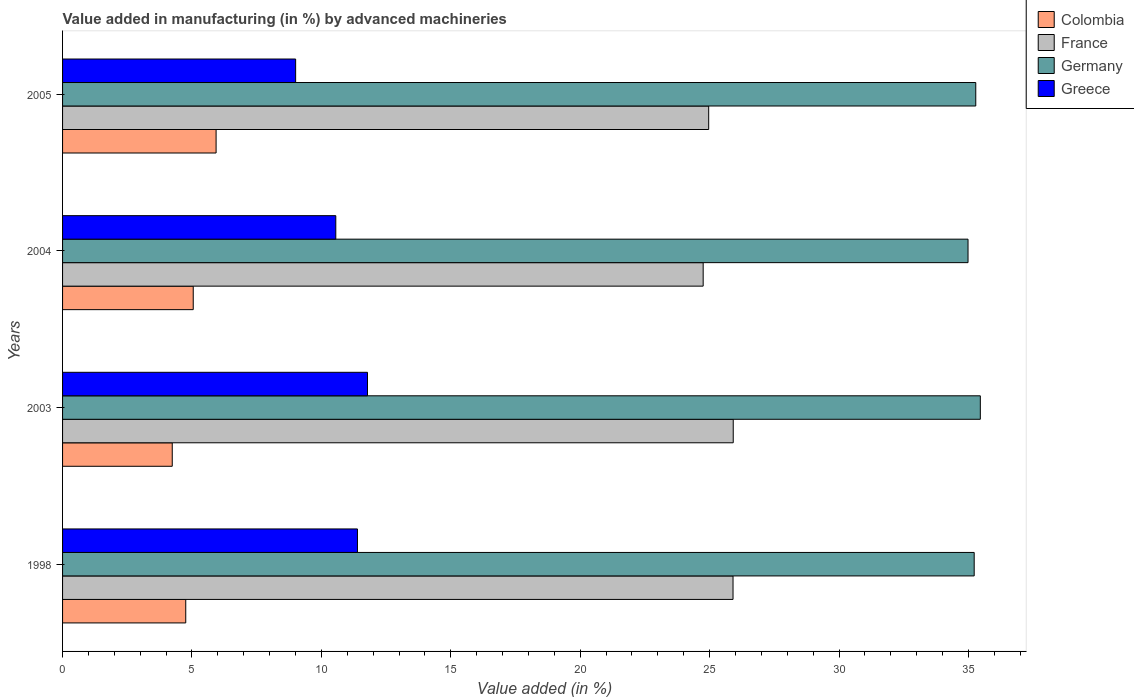Are the number of bars per tick equal to the number of legend labels?
Offer a terse response. Yes. How many bars are there on the 2nd tick from the bottom?
Ensure brevity in your answer.  4. What is the percentage of value added in manufacturing by advanced machineries in France in 2005?
Give a very brief answer. 24.96. Across all years, what is the maximum percentage of value added in manufacturing by advanced machineries in Germany?
Make the answer very short. 35.46. Across all years, what is the minimum percentage of value added in manufacturing by advanced machineries in Greece?
Provide a short and direct response. 9. What is the total percentage of value added in manufacturing by advanced machineries in France in the graph?
Your response must be concise. 101.53. What is the difference between the percentage of value added in manufacturing by advanced machineries in France in 2004 and that in 2005?
Your answer should be compact. -0.21. What is the difference between the percentage of value added in manufacturing by advanced machineries in Greece in 1998 and the percentage of value added in manufacturing by advanced machineries in Germany in 2003?
Offer a very short reply. -24.06. What is the average percentage of value added in manufacturing by advanced machineries in Colombia per year?
Provide a short and direct response. 4.99. In the year 2004, what is the difference between the percentage of value added in manufacturing by advanced machineries in France and percentage of value added in manufacturing by advanced machineries in Greece?
Your answer should be very brief. 14.19. What is the ratio of the percentage of value added in manufacturing by advanced machineries in Germany in 1998 to that in 2003?
Make the answer very short. 0.99. What is the difference between the highest and the second highest percentage of value added in manufacturing by advanced machineries in France?
Keep it short and to the point. 0.01. What is the difference between the highest and the lowest percentage of value added in manufacturing by advanced machineries in Germany?
Offer a very short reply. 0.48. Is it the case that in every year, the sum of the percentage of value added in manufacturing by advanced machineries in Colombia and percentage of value added in manufacturing by advanced machineries in Greece is greater than the sum of percentage of value added in manufacturing by advanced machineries in France and percentage of value added in manufacturing by advanced machineries in Germany?
Your answer should be very brief. No. What does the 1st bar from the top in 2004 represents?
Offer a terse response. Greece. What does the 2nd bar from the bottom in 2005 represents?
Keep it short and to the point. France. Is it the case that in every year, the sum of the percentage of value added in manufacturing by advanced machineries in France and percentage of value added in manufacturing by advanced machineries in Colombia is greater than the percentage of value added in manufacturing by advanced machineries in Germany?
Provide a succinct answer. No. How many bars are there?
Provide a short and direct response. 16. Are all the bars in the graph horizontal?
Provide a succinct answer. Yes. Where does the legend appear in the graph?
Ensure brevity in your answer.  Top right. How many legend labels are there?
Keep it short and to the point. 4. How are the legend labels stacked?
Keep it short and to the point. Vertical. What is the title of the graph?
Your response must be concise. Value added in manufacturing (in %) by advanced machineries. What is the label or title of the X-axis?
Give a very brief answer. Value added (in %). What is the Value added (in %) of Colombia in 1998?
Your response must be concise. 4.76. What is the Value added (in %) in France in 1998?
Give a very brief answer. 25.9. What is the Value added (in %) of Germany in 1998?
Keep it short and to the point. 35.22. What is the Value added (in %) of Greece in 1998?
Offer a very short reply. 11.39. What is the Value added (in %) in Colombia in 2003?
Give a very brief answer. 4.24. What is the Value added (in %) of France in 2003?
Your response must be concise. 25.91. What is the Value added (in %) of Germany in 2003?
Provide a short and direct response. 35.46. What is the Value added (in %) in Greece in 2003?
Your answer should be very brief. 11.78. What is the Value added (in %) of Colombia in 2004?
Ensure brevity in your answer.  5.05. What is the Value added (in %) of France in 2004?
Your answer should be very brief. 24.75. What is the Value added (in %) of Germany in 2004?
Provide a short and direct response. 34.98. What is the Value added (in %) of Greece in 2004?
Give a very brief answer. 10.56. What is the Value added (in %) of Colombia in 2005?
Provide a short and direct response. 5.93. What is the Value added (in %) in France in 2005?
Your answer should be very brief. 24.96. What is the Value added (in %) of Germany in 2005?
Keep it short and to the point. 35.28. What is the Value added (in %) of Greece in 2005?
Offer a very short reply. 9. Across all years, what is the maximum Value added (in %) of Colombia?
Give a very brief answer. 5.93. Across all years, what is the maximum Value added (in %) in France?
Provide a succinct answer. 25.91. Across all years, what is the maximum Value added (in %) in Germany?
Provide a succinct answer. 35.46. Across all years, what is the maximum Value added (in %) of Greece?
Provide a short and direct response. 11.78. Across all years, what is the minimum Value added (in %) of Colombia?
Your answer should be very brief. 4.24. Across all years, what is the minimum Value added (in %) of France?
Ensure brevity in your answer.  24.75. Across all years, what is the minimum Value added (in %) in Germany?
Keep it short and to the point. 34.98. Across all years, what is the minimum Value added (in %) of Greece?
Give a very brief answer. 9. What is the total Value added (in %) of Colombia in the graph?
Your response must be concise. 19.98. What is the total Value added (in %) in France in the graph?
Your answer should be compact. 101.53. What is the total Value added (in %) of Germany in the graph?
Make the answer very short. 140.95. What is the total Value added (in %) in Greece in the graph?
Your response must be concise. 42.74. What is the difference between the Value added (in %) of Colombia in 1998 and that in 2003?
Give a very brief answer. 0.52. What is the difference between the Value added (in %) of France in 1998 and that in 2003?
Provide a short and direct response. -0.01. What is the difference between the Value added (in %) in Germany in 1998 and that in 2003?
Provide a succinct answer. -0.24. What is the difference between the Value added (in %) of Greece in 1998 and that in 2003?
Your answer should be compact. -0.39. What is the difference between the Value added (in %) in Colombia in 1998 and that in 2004?
Keep it short and to the point. -0.29. What is the difference between the Value added (in %) of France in 1998 and that in 2004?
Provide a succinct answer. 1.15. What is the difference between the Value added (in %) of Germany in 1998 and that in 2004?
Your answer should be very brief. 0.24. What is the difference between the Value added (in %) in Greece in 1998 and that in 2004?
Your response must be concise. 0.84. What is the difference between the Value added (in %) of Colombia in 1998 and that in 2005?
Your response must be concise. -1.17. What is the difference between the Value added (in %) in France in 1998 and that in 2005?
Make the answer very short. 0.94. What is the difference between the Value added (in %) in Germany in 1998 and that in 2005?
Provide a short and direct response. -0.06. What is the difference between the Value added (in %) in Greece in 1998 and that in 2005?
Provide a succinct answer. 2.39. What is the difference between the Value added (in %) of Colombia in 2003 and that in 2004?
Offer a terse response. -0.81. What is the difference between the Value added (in %) in France in 2003 and that in 2004?
Your answer should be very brief. 1.16. What is the difference between the Value added (in %) of Germany in 2003 and that in 2004?
Offer a very short reply. 0.48. What is the difference between the Value added (in %) in Greece in 2003 and that in 2004?
Offer a terse response. 1.22. What is the difference between the Value added (in %) of Colombia in 2003 and that in 2005?
Ensure brevity in your answer.  -1.69. What is the difference between the Value added (in %) in France in 2003 and that in 2005?
Keep it short and to the point. 0.95. What is the difference between the Value added (in %) in Germany in 2003 and that in 2005?
Your response must be concise. 0.18. What is the difference between the Value added (in %) in Greece in 2003 and that in 2005?
Provide a short and direct response. 2.78. What is the difference between the Value added (in %) of Colombia in 2004 and that in 2005?
Keep it short and to the point. -0.88. What is the difference between the Value added (in %) in France in 2004 and that in 2005?
Make the answer very short. -0.21. What is the difference between the Value added (in %) of Germany in 2004 and that in 2005?
Give a very brief answer. -0.3. What is the difference between the Value added (in %) of Greece in 2004 and that in 2005?
Offer a very short reply. 1.55. What is the difference between the Value added (in %) of Colombia in 1998 and the Value added (in %) of France in 2003?
Offer a very short reply. -21.15. What is the difference between the Value added (in %) of Colombia in 1998 and the Value added (in %) of Germany in 2003?
Provide a short and direct response. -30.7. What is the difference between the Value added (in %) in Colombia in 1998 and the Value added (in %) in Greece in 2003?
Provide a succinct answer. -7.02. What is the difference between the Value added (in %) of France in 1998 and the Value added (in %) of Germany in 2003?
Provide a short and direct response. -9.55. What is the difference between the Value added (in %) in France in 1998 and the Value added (in %) in Greece in 2003?
Keep it short and to the point. 14.12. What is the difference between the Value added (in %) in Germany in 1998 and the Value added (in %) in Greece in 2003?
Make the answer very short. 23.44. What is the difference between the Value added (in %) of Colombia in 1998 and the Value added (in %) of France in 2004?
Your answer should be compact. -19.99. What is the difference between the Value added (in %) of Colombia in 1998 and the Value added (in %) of Germany in 2004?
Your response must be concise. -30.22. What is the difference between the Value added (in %) in Colombia in 1998 and the Value added (in %) in Greece in 2004?
Give a very brief answer. -5.8. What is the difference between the Value added (in %) in France in 1998 and the Value added (in %) in Germany in 2004?
Offer a very short reply. -9.08. What is the difference between the Value added (in %) of France in 1998 and the Value added (in %) of Greece in 2004?
Give a very brief answer. 15.35. What is the difference between the Value added (in %) in Germany in 1998 and the Value added (in %) in Greece in 2004?
Offer a terse response. 24.66. What is the difference between the Value added (in %) of Colombia in 1998 and the Value added (in %) of France in 2005?
Make the answer very short. -20.2. What is the difference between the Value added (in %) in Colombia in 1998 and the Value added (in %) in Germany in 2005?
Provide a succinct answer. -30.52. What is the difference between the Value added (in %) of Colombia in 1998 and the Value added (in %) of Greece in 2005?
Your answer should be compact. -4.25. What is the difference between the Value added (in %) in France in 1998 and the Value added (in %) in Germany in 2005?
Your answer should be very brief. -9.38. What is the difference between the Value added (in %) of France in 1998 and the Value added (in %) of Greece in 2005?
Give a very brief answer. 16.9. What is the difference between the Value added (in %) of Germany in 1998 and the Value added (in %) of Greece in 2005?
Make the answer very short. 26.22. What is the difference between the Value added (in %) of Colombia in 2003 and the Value added (in %) of France in 2004?
Your answer should be very brief. -20.51. What is the difference between the Value added (in %) of Colombia in 2003 and the Value added (in %) of Germany in 2004?
Your answer should be compact. -30.75. What is the difference between the Value added (in %) in Colombia in 2003 and the Value added (in %) in Greece in 2004?
Offer a terse response. -6.32. What is the difference between the Value added (in %) of France in 2003 and the Value added (in %) of Germany in 2004?
Your response must be concise. -9.07. What is the difference between the Value added (in %) in France in 2003 and the Value added (in %) in Greece in 2004?
Make the answer very short. 15.36. What is the difference between the Value added (in %) in Germany in 2003 and the Value added (in %) in Greece in 2004?
Your answer should be compact. 24.9. What is the difference between the Value added (in %) of Colombia in 2003 and the Value added (in %) of France in 2005?
Give a very brief answer. -20.73. What is the difference between the Value added (in %) of Colombia in 2003 and the Value added (in %) of Germany in 2005?
Your answer should be very brief. -31.04. What is the difference between the Value added (in %) in Colombia in 2003 and the Value added (in %) in Greece in 2005?
Give a very brief answer. -4.77. What is the difference between the Value added (in %) in France in 2003 and the Value added (in %) in Germany in 2005?
Offer a terse response. -9.37. What is the difference between the Value added (in %) in France in 2003 and the Value added (in %) in Greece in 2005?
Provide a short and direct response. 16.91. What is the difference between the Value added (in %) of Germany in 2003 and the Value added (in %) of Greece in 2005?
Your answer should be very brief. 26.45. What is the difference between the Value added (in %) of Colombia in 2004 and the Value added (in %) of France in 2005?
Your answer should be compact. -19.91. What is the difference between the Value added (in %) in Colombia in 2004 and the Value added (in %) in Germany in 2005?
Your answer should be very brief. -30.23. What is the difference between the Value added (in %) in Colombia in 2004 and the Value added (in %) in Greece in 2005?
Your response must be concise. -3.96. What is the difference between the Value added (in %) in France in 2004 and the Value added (in %) in Germany in 2005?
Offer a terse response. -10.53. What is the difference between the Value added (in %) in France in 2004 and the Value added (in %) in Greece in 2005?
Keep it short and to the point. 15.75. What is the difference between the Value added (in %) in Germany in 2004 and the Value added (in %) in Greece in 2005?
Ensure brevity in your answer.  25.98. What is the average Value added (in %) in Colombia per year?
Make the answer very short. 4.99. What is the average Value added (in %) of France per year?
Make the answer very short. 25.38. What is the average Value added (in %) of Germany per year?
Give a very brief answer. 35.24. What is the average Value added (in %) in Greece per year?
Your answer should be very brief. 10.68. In the year 1998, what is the difference between the Value added (in %) in Colombia and Value added (in %) in France?
Offer a terse response. -21.14. In the year 1998, what is the difference between the Value added (in %) in Colombia and Value added (in %) in Germany?
Provide a succinct answer. -30.46. In the year 1998, what is the difference between the Value added (in %) in Colombia and Value added (in %) in Greece?
Your response must be concise. -6.63. In the year 1998, what is the difference between the Value added (in %) of France and Value added (in %) of Germany?
Keep it short and to the point. -9.32. In the year 1998, what is the difference between the Value added (in %) in France and Value added (in %) in Greece?
Your response must be concise. 14.51. In the year 1998, what is the difference between the Value added (in %) in Germany and Value added (in %) in Greece?
Offer a terse response. 23.83. In the year 2003, what is the difference between the Value added (in %) of Colombia and Value added (in %) of France?
Offer a terse response. -21.67. In the year 2003, what is the difference between the Value added (in %) of Colombia and Value added (in %) of Germany?
Provide a short and direct response. -31.22. In the year 2003, what is the difference between the Value added (in %) in Colombia and Value added (in %) in Greece?
Your response must be concise. -7.54. In the year 2003, what is the difference between the Value added (in %) of France and Value added (in %) of Germany?
Your answer should be compact. -9.55. In the year 2003, what is the difference between the Value added (in %) in France and Value added (in %) in Greece?
Your answer should be compact. 14.13. In the year 2003, what is the difference between the Value added (in %) in Germany and Value added (in %) in Greece?
Offer a terse response. 23.68. In the year 2004, what is the difference between the Value added (in %) of Colombia and Value added (in %) of France?
Ensure brevity in your answer.  -19.7. In the year 2004, what is the difference between the Value added (in %) in Colombia and Value added (in %) in Germany?
Make the answer very short. -29.93. In the year 2004, what is the difference between the Value added (in %) in Colombia and Value added (in %) in Greece?
Give a very brief answer. -5.51. In the year 2004, what is the difference between the Value added (in %) of France and Value added (in %) of Germany?
Keep it short and to the point. -10.23. In the year 2004, what is the difference between the Value added (in %) of France and Value added (in %) of Greece?
Give a very brief answer. 14.19. In the year 2004, what is the difference between the Value added (in %) in Germany and Value added (in %) in Greece?
Ensure brevity in your answer.  24.43. In the year 2005, what is the difference between the Value added (in %) of Colombia and Value added (in %) of France?
Provide a short and direct response. -19.03. In the year 2005, what is the difference between the Value added (in %) of Colombia and Value added (in %) of Germany?
Provide a succinct answer. -29.35. In the year 2005, what is the difference between the Value added (in %) in Colombia and Value added (in %) in Greece?
Ensure brevity in your answer.  -3.07. In the year 2005, what is the difference between the Value added (in %) in France and Value added (in %) in Germany?
Provide a short and direct response. -10.32. In the year 2005, what is the difference between the Value added (in %) in France and Value added (in %) in Greece?
Give a very brief answer. 15.96. In the year 2005, what is the difference between the Value added (in %) in Germany and Value added (in %) in Greece?
Your answer should be very brief. 26.28. What is the ratio of the Value added (in %) in Colombia in 1998 to that in 2003?
Give a very brief answer. 1.12. What is the ratio of the Value added (in %) of Germany in 1998 to that in 2003?
Keep it short and to the point. 0.99. What is the ratio of the Value added (in %) of Greece in 1998 to that in 2003?
Keep it short and to the point. 0.97. What is the ratio of the Value added (in %) of Colombia in 1998 to that in 2004?
Make the answer very short. 0.94. What is the ratio of the Value added (in %) of France in 1998 to that in 2004?
Ensure brevity in your answer.  1.05. What is the ratio of the Value added (in %) in Germany in 1998 to that in 2004?
Provide a succinct answer. 1.01. What is the ratio of the Value added (in %) of Greece in 1998 to that in 2004?
Your answer should be very brief. 1.08. What is the ratio of the Value added (in %) of Colombia in 1998 to that in 2005?
Offer a very short reply. 0.8. What is the ratio of the Value added (in %) of France in 1998 to that in 2005?
Ensure brevity in your answer.  1.04. What is the ratio of the Value added (in %) of Germany in 1998 to that in 2005?
Provide a short and direct response. 1. What is the ratio of the Value added (in %) in Greece in 1998 to that in 2005?
Ensure brevity in your answer.  1.27. What is the ratio of the Value added (in %) of Colombia in 2003 to that in 2004?
Give a very brief answer. 0.84. What is the ratio of the Value added (in %) of France in 2003 to that in 2004?
Your answer should be compact. 1.05. What is the ratio of the Value added (in %) of Germany in 2003 to that in 2004?
Provide a succinct answer. 1.01. What is the ratio of the Value added (in %) of Greece in 2003 to that in 2004?
Your answer should be compact. 1.12. What is the ratio of the Value added (in %) in Colombia in 2003 to that in 2005?
Offer a very short reply. 0.71. What is the ratio of the Value added (in %) of France in 2003 to that in 2005?
Provide a short and direct response. 1.04. What is the ratio of the Value added (in %) of Greece in 2003 to that in 2005?
Make the answer very short. 1.31. What is the ratio of the Value added (in %) in Colombia in 2004 to that in 2005?
Offer a very short reply. 0.85. What is the ratio of the Value added (in %) of Greece in 2004 to that in 2005?
Make the answer very short. 1.17. What is the difference between the highest and the second highest Value added (in %) in Colombia?
Offer a terse response. 0.88. What is the difference between the highest and the second highest Value added (in %) of France?
Provide a succinct answer. 0.01. What is the difference between the highest and the second highest Value added (in %) of Germany?
Your answer should be compact. 0.18. What is the difference between the highest and the second highest Value added (in %) in Greece?
Your response must be concise. 0.39. What is the difference between the highest and the lowest Value added (in %) of Colombia?
Provide a succinct answer. 1.69. What is the difference between the highest and the lowest Value added (in %) in France?
Your answer should be very brief. 1.16. What is the difference between the highest and the lowest Value added (in %) in Germany?
Offer a terse response. 0.48. What is the difference between the highest and the lowest Value added (in %) in Greece?
Provide a short and direct response. 2.78. 